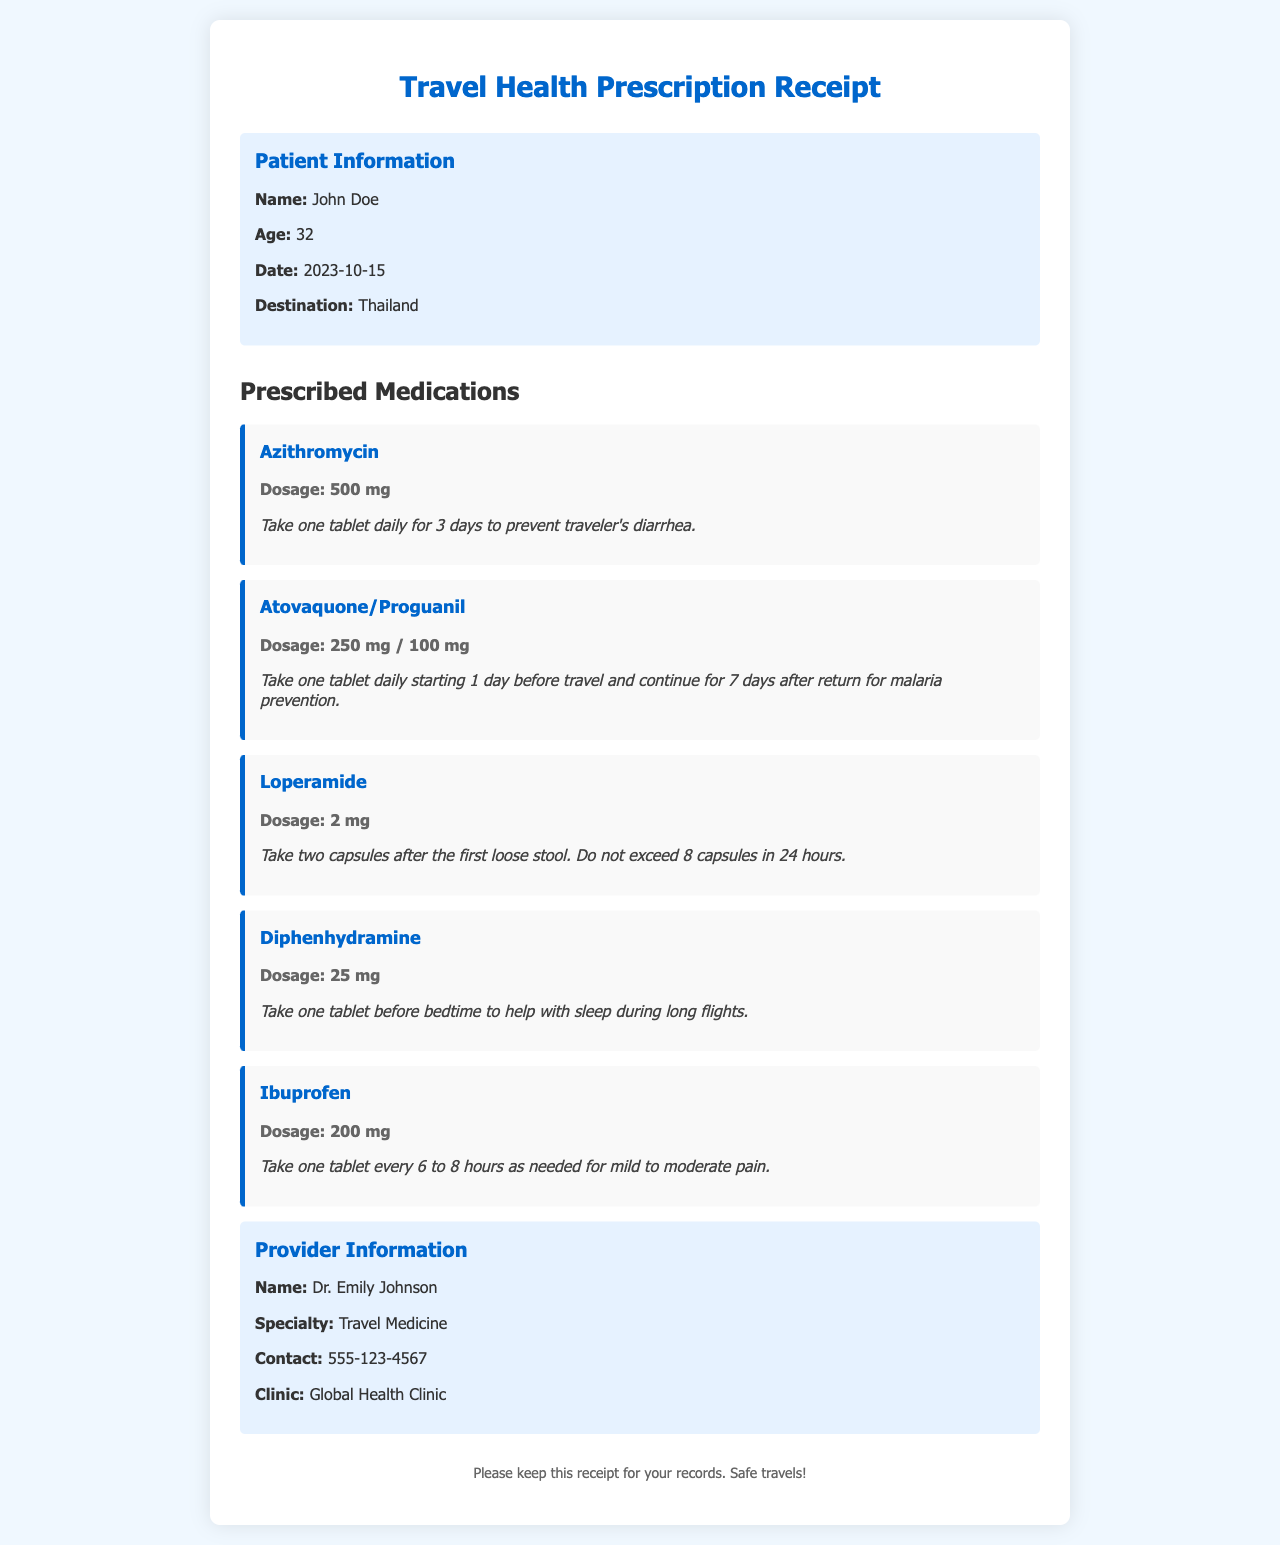What is the patient's name? The patient's name is listed in the patient information section of the document.
Answer: John Doe What medication is prescribed for traveler's diarrhea? The medication for traveler's diarrhea is specified in the prescribed medications section.
Answer: Azithromycin How many days should Atovaquone/Proguanil be taken? The instructions indicate a specific duration for taking Atovaquone/Proguanil.
Answer: 8 days What is the dosage of Loperamide? The dosage for Loperamide is specified in the medication section of the receipt.
Answer: 2 mg Who is the healthcare provider? The name of the healthcare provider is listed in the provider information section.
Answer: Dr. Emily Johnson How should Diphenhydramine be taken? The instruction for taking Diphenhydramine is contained in the medication section of the document.
Answer: Before bedtime What is the age of the patient? The patient's age is specified in the patient information section of the document.
Answer: 32 What is the contact number of the provider? The contact information for the provider is included in the provider information section.
Answer: 555-123-4567 What condition does the provider specialize in? The provider's specialty is indicated in the provider information section.
Answer: Travel Medicine 